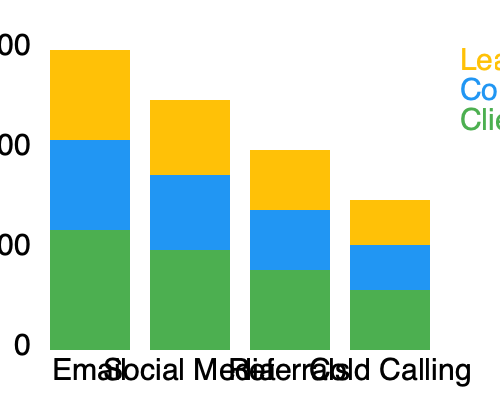As an independent insurance agent, you're analyzing the effectiveness of different marketing channels. Based on the stacked bar graph showing lead generation, conversion rate, and client retention for various channels, which marketing channel should you prioritize to maximize overall client acquisition and retention? To determine the most effective marketing channel, we need to analyze each aspect of the graph:

1. Lead Generation (yellow):
   - Email: 90
   - Social Media: 75
   - Referrals: 60
   - Cold Calling: 45

2. Conversion Rate (blue):
   - Email: 90
   - Social Media: 75
   - Referrals: 60
   - Cold Calling: 45

3. Client Retention (green):
   - Email: 120
   - Social Media: 100
   - Referrals: 80
   - Cold Calling: 60

4. Total effectiveness (sum of all three metrics):
   - Email: 90 + 90 + 120 = 300
   - Social Media: 75 + 75 + 100 = 250
   - Referrals: 60 + 60 + 80 = 200
   - Cold Calling: 45 + 45 + 60 = 150

5. Analysis:
   - Email has the highest scores in all three categories.
   - It generates the most leads, has the highest conversion rate, and retains clients best.
   - The total effectiveness score for email (300) is significantly higher than the next best channel, social media (250).

Therefore, to maximize overall client acquisition and retention, the independent insurance agent should prioritize email marketing.
Answer: Email marketing 